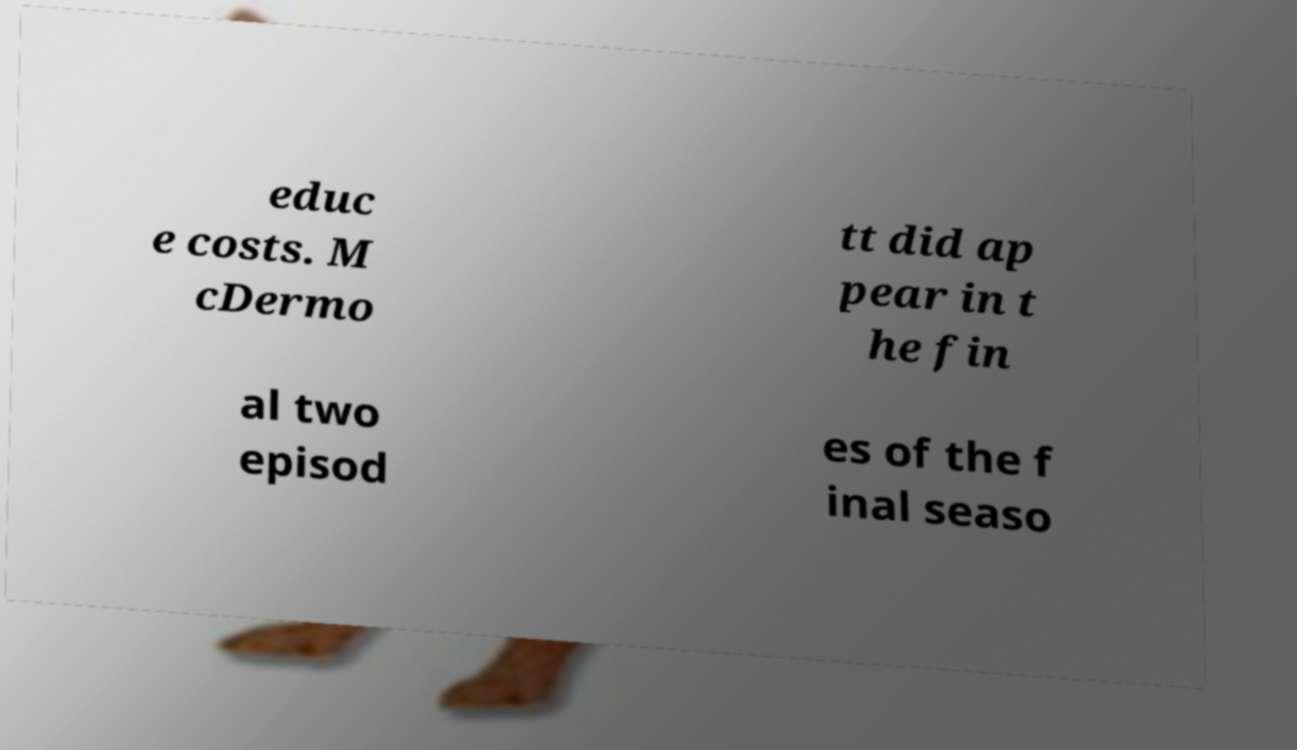For documentation purposes, I need the text within this image transcribed. Could you provide that? educ e costs. M cDermo tt did ap pear in t he fin al two episod es of the f inal seaso 